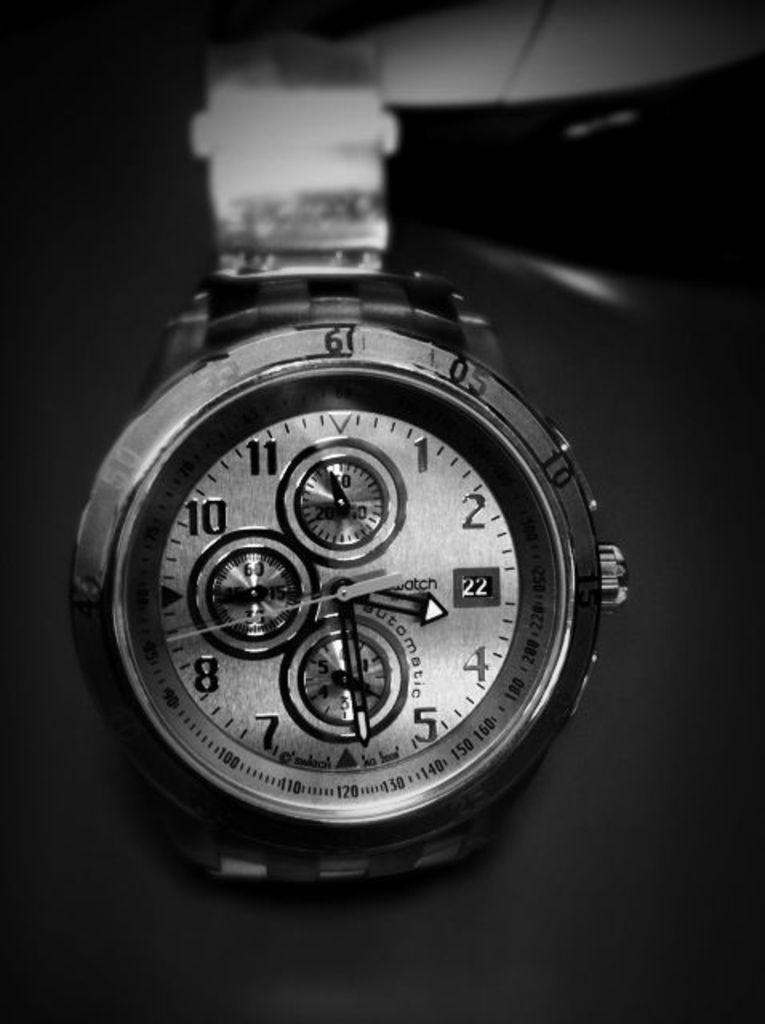<image>
Offer a succinct explanation of the picture presented. Swatch watch that displays the date as 22. 